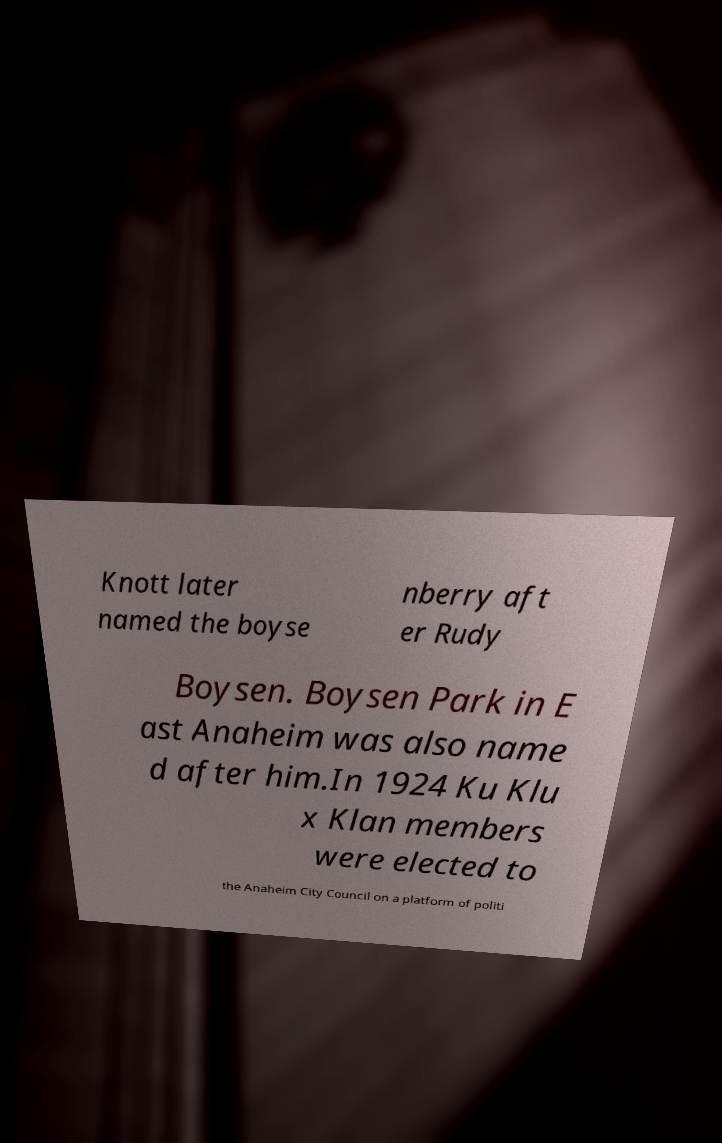For documentation purposes, I need the text within this image transcribed. Could you provide that? Knott later named the boyse nberry aft er Rudy Boysen. Boysen Park in E ast Anaheim was also name d after him.In 1924 Ku Klu x Klan members were elected to the Anaheim City Council on a platform of politi 